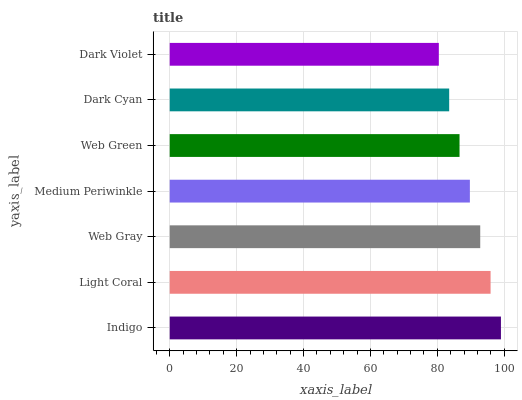Is Dark Violet the minimum?
Answer yes or no. Yes. Is Indigo the maximum?
Answer yes or no. Yes. Is Light Coral the minimum?
Answer yes or no. No. Is Light Coral the maximum?
Answer yes or no. No. Is Indigo greater than Light Coral?
Answer yes or no. Yes. Is Light Coral less than Indigo?
Answer yes or no. Yes. Is Light Coral greater than Indigo?
Answer yes or no. No. Is Indigo less than Light Coral?
Answer yes or no. No. Is Medium Periwinkle the high median?
Answer yes or no. Yes. Is Medium Periwinkle the low median?
Answer yes or no. Yes. Is Web Green the high median?
Answer yes or no. No. Is Light Coral the low median?
Answer yes or no. No. 